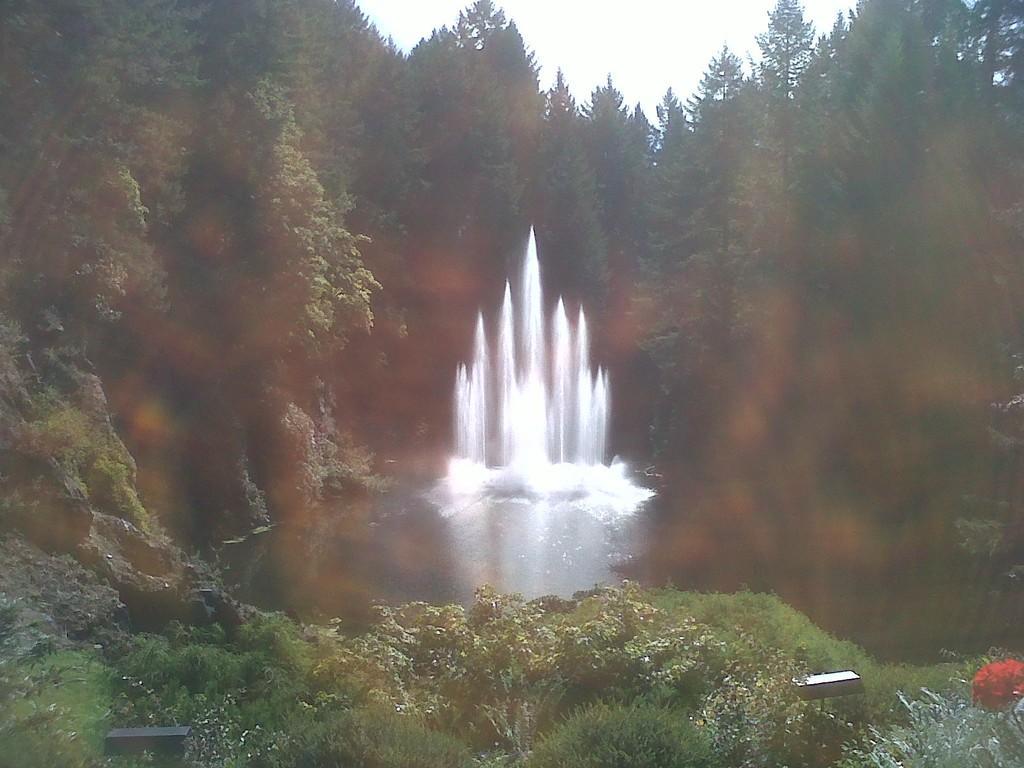How would you summarize this image in a sentence or two? This image consists of a waterfall. At the bottom, there are small plants. In the background, there are many trees. At the top, there is a sky. 